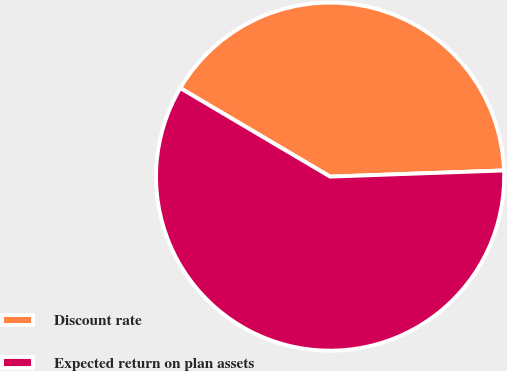<chart> <loc_0><loc_0><loc_500><loc_500><pie_chart><fcel>Discount rate<fcel>Expected return on plan assets<nl><fcel>40.94%<fcel>59.06%<nl></chart> 